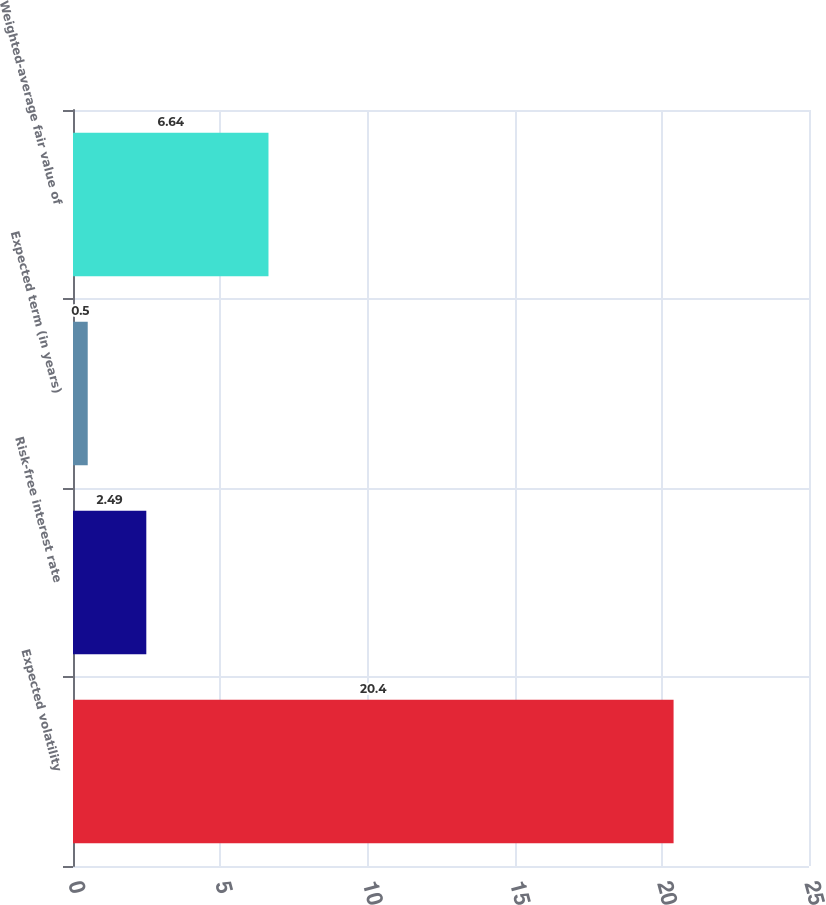Convert chart to OTSL. <chart><loc_0><loc_0><loc_500><loc_500><bar_chart><fcel>Expected volatility<fcel>Risk-free interest rate<fcel>Expected term (in years)<fcel>Weighted-average fair value of<nl><fcel>20.4<fcel>2.49<fcel>0.5<fcel>6.64<nl></chart> 